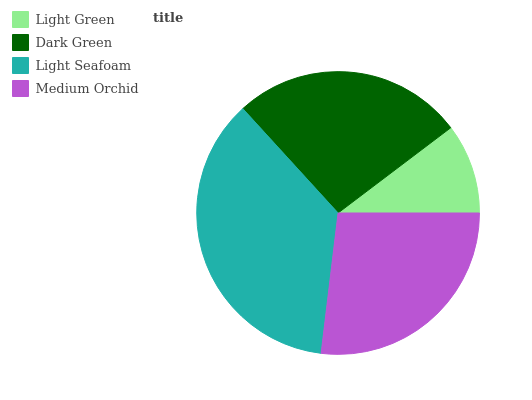Is Light Green the minimum?
Answer yes or no. Yes. Is Light Seafoam the maximum?
Answer yes or no. Yes. Is Dark Green the minimum?
Answer yes or no. No. Is Dark Green the maximum?
Answer yes or no. No. Is Dark Green greater than Light Green?
Answer yes or no. Yes. Is Light Green less than Dark Green?
Answer yes or no. Yes. Is Light Green greater than Dark Green?
Answer yes or no. No. Is Dark Green less than Light Green?
Answer yes or no. No. Is Medium Orchid the high median?
Answer yes or no. Yes. Is Dark Green the low median?
Answer yes or no. Yes. Is Dark Green the high median?
Answer yes or no. No. Is Light Green the low median?
Answer yes or no. No. 